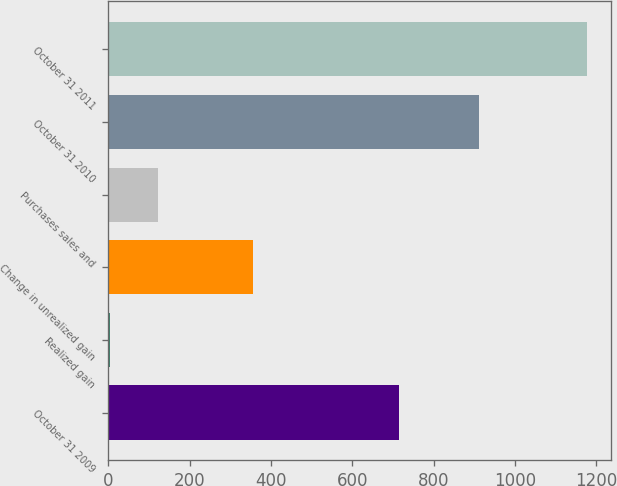Convert chart. <chart><loc_0><loc_0><loc_500><loc_500><bar_chart><fcel>October 31 2009<fcel>Realized gain<fcel>Change in unrealized gain<fcel>Purchases sales and<fcel>October 31 2010<fcel>October 31 2011<nl><fcel>716<fcel>4<fcel>356.2<fcel>121.4<fcel>912<fcel>1178<nl></chart> 